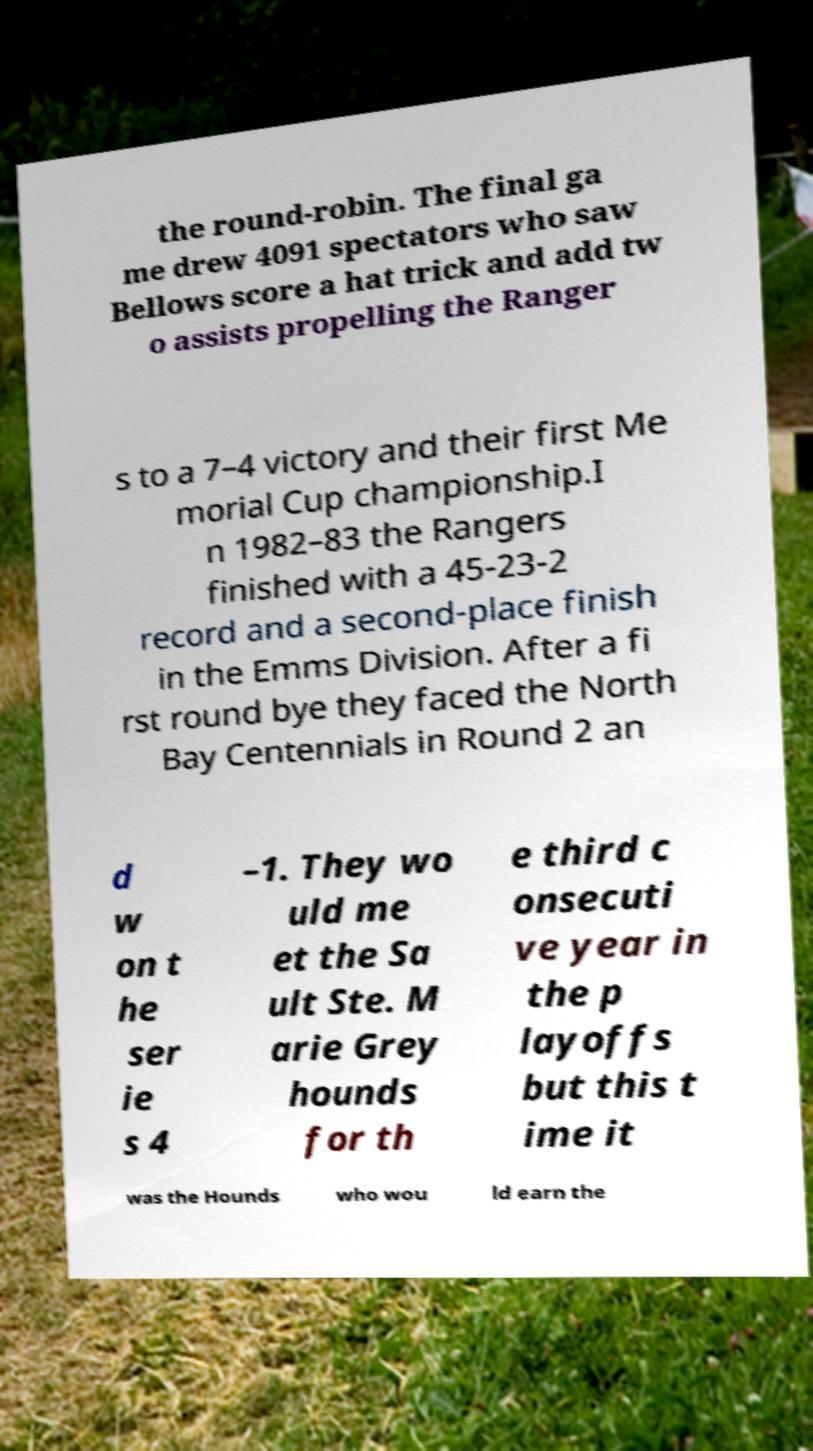Could you assist in decoding the text presented in this image and type it out clearly? the round-robin. The final ga me drew 4091 spectators who saw Bellows score a hat trick and add tw o assists propelling the Ranger s to a 7–4 victory and their first Me morial Cup championship.I n 1982–83 the Rangers finished with a 45-23-2 record and a second-place finish in the Emms Division. After a fi rst round bye they faced the North Bay Centennials in Round 2 an d w on t he ser ie s 4 –1. They wo uld me et the Sa ult Ste. M arie Grey hounds for th e third c onsecuti ve year in the p layoffs but this t ime it was the Hounds who wou ld earn the 